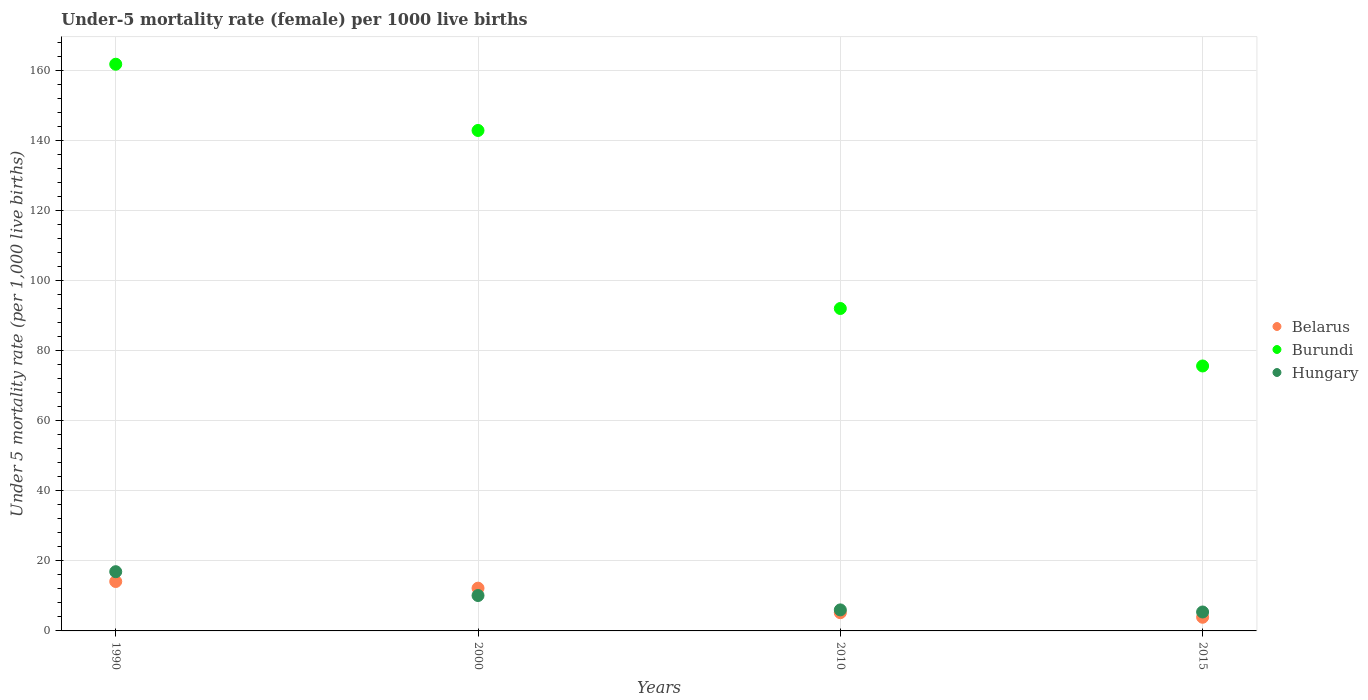What is the under-five mortality rate in Burundi in 2015?
Offer a terse response. 75.6. Across all years, what is the minimum under-five mortality rate in Hungary?
Offer a very short reply. 5.4. In which year was the under-five mortality rate in Hungary minimum?
Provide a short and direct response. 2015. What is the total under-five mortality rate in Hungary in the graph?
Your answer should be compact. 38.4. What is the difference between the under-five mortality rate in Belarus in 1990 and that in 2010?
Your answer should be very brief. 8.9. What is the difference between the under-five mortality rate in Hungary in 2015 and the under-five mortality rate in Burundi in 1990?
Your answer should be compact. -156.3. What is the average under-five mortality rate in Belarus per year?
Make the answer very short. 8.85. In the year 2010, what is the difference between the under-five mortality rate in Hungary and under-five mortality rate in Burundi?
Provide a succinct answer. -86. What is the ratio of the under-five mortality rate in Burundi in 1990 to that in 2015?
Ensure brevity in your answer.  2.14. Is the under-five mortality rate in Belarus in 1990 less than that in 2010?
Give a very brief answer. No. What is the difference between the highest and the second highest under-five mortality rate in Burundi?
Your response must be concise. 18.9. What is the difference between the highest and the lowest under-five mortality rate in Hungary?
Offer a terse response. 11.5. Is the sum of the under-five mortality rate in Hungary in 1990 and 2015 greater than the maximum under-five mortality rate in Belarus across all years?
Your answer should be very brief. Yes. Is the under-five mortality rate in Hungary strictly less than the under-five mortality rate in Belarus over the years?
Ensure brevity in your answer.  No. How many dotlines are there?
Give a very brief answer. 3. How many legend labels are there?
Your answer should be compact. 3. How are the legend labels stacked?
Your answer should be very brief. Vertical. What is the title of the graph?
Ensure brevity in your answer.  Under-5 mortality rate (female) per 1000 live births. What is the label or title of the X-axis?
Provide a succinct answer. Years. What is the label or title of the Y-axis?
Provide a succinct answer. Under 5 mortality rate (per 1,0 live births). What is the Under 5 mortality rate (per 1,000 live births) in Belarus in 1990?
Make the answer very short. 14.1. What is the Under 5 mortality rate (per 1,000 live births) of Burundi in 1990?
Your answer should be very brief. 161.7. What is the Under 5 mortality rate (per 1,000 live births) of Hungary in 1990?
Offer a terse response. 16.9. What is the Under 5 mortality rate (per 1,000 live births) in Burundi in 2000?
Provide a short and direct response. 142.8. What is the Under 5 mortality rate (per 1,000 live births) of Hungary in 2000?
Provide a short and direct response. 10.1. What is the Under 5 mortality rate (per 1,000 live births) in Burundi in 2010?
Your response must be concise. 92. What is the Under 5 mortality rate (per 1,000 live births) of Burundi in 2015?
Offer a terse response. 75.6. Across all years, what is the maximum Under 5 mortality rate (per 1,000 live births) of Belarus?
Offer a very short reply. 14.1. Across all years, what is the maximum Under 5 mortality rate (per 1,000 live births) of Burundi?
Give a very brief answer. 161.7. Across all years, what is the maximum Under 5 mortality rate (per 1,000 live births) in Hungary?
Keep it short and to the point. 16.9. Across all years, what is the minimum Under 5 mortality rate (per 1,000 live births) of Belarus?
Your response must be concise. 3.9. Across all years, what is the minimum Under 5 mortality rate (per 1,000 live births) of Burundi?
Your answer should be compact. 75.6. Across all years, what is the minimum Under 5 mortality rate (per 1,000 live births) of Hungary?
Provide a short and direct response. 5.4. What is the total Under 5 mortality rate (per 1,000 live births) of Belarus in the graph?
Offer a terse response. 35.4. What is the total Under 5 mortality rate (per 1,000 live births) of Burundi in the graph?
Provide a succinct answer. 472.1. What is the total Under 5 mortality rate (per 1,000 live births) in Hungary in the graph?
Ensure brevity in your answer.  38.4. What is the difference between the Under 5 mortality rate (per 1,000 live births) of Belarus in 1990 and that in 2000?
Provide a short and direct response. 1.9. What is the difference between the Under 5 mortality rate (per 1,000 live births) in Burundi in 1990 and that in 2010?
Ensure brevity in your answer.  69.7. What is the difference between the Under 5 mortality rate (per 1,000 live births) in Burundi in 1990 and that in 2015?
Make the answer very short. 86.1. What is the difference between the Under 5 mortality rate (per 1,000 live births) in Belarus in 2000 and that in 2010?
Provide a succinct answer. 7. What is the difference between the Under 5 mortality rate (per 1,000 live births) of Burundi in 2000 and that in 2010?
Give a very brief answer. 50.8. What is the difference between the Under 5 mortality rate (per 1,000 live births) of Belarus in 2000 and that in 2015?
Give a very brief answer. 8.3. What is the difference between the Under 5 mortality rate (per 1,000 live births) in Burundi in 2000 and that in 2015?
Provide a succinct answer. 67.2. What is the difference between the Under 5 mortality rate (per 1,000 live births) in Hungary in 2000 and that in 2015?
Make the answer very short. 4.7. What is the difference between the Under 5 mortality rate (per 1,000 live births) of Burundi in 2010 and that in 2015?
Keep it short and to the point. 16.4. What is the difference between the Under 5 mortality rate (per 1,000 live births) of Hungary in 2010 and that in 2015?
Give a very brief answer. 0.6. What is the difference between the Under 5 mortality rate (per 1,000 live births) in Belarus in 1990 and the Under 5 mortality rate (per 1,000 live births) in Burundi in 2000?
Your answer should be compact. -128.7. What is the difference between the Under 5 mortality rate (per 1,000 live births) of Burundi in 1990 and the Under 5 mortality rate (per 1,000 live births) of Hungary in 2000?
Make the answer very short. 151.6. What is the difference between the Under 5 mortality rate (per 1,000 live births) of Belarus in 1990 and the Under 5 mortality rate (per 1,000 live births) of Burundi in 2010?
Your answer should be very brief. -77.9. What is the difference between the Under 5 mortality rate (per 1,000 live births) in Burundi in 1990 and the Under 5 mortality rate (per 1,000 live births) in Hungary in 2010?
Offer a very short reply. 155.7. What is the difference between the Under 5 mortality rate (per 1,000 live births) in Belarus in 1990 and the Under 5 mortality rate (per 1,000 live births) in Burundi in 2015?
Your answer should be compact. -61.5. What is the difference between the Under 5 mortality rate (per 1,000 live births) in Belarus in 1990 and the Under 5 mortality rate (per 1,000 live births) in Hungary in 2015?
Offer a terse response. 8.7. What is the difference between the Under 5 mortality rate (per 1,000 live births) in Burundi in 1990 and the Under 5 mortality rate (per 1,000 live births) in Hungary in 2015?
Provide a short and direct response. 156.3. What is the difference between the Under 5 mortality rate (per 1,000 live births) of Belarus in 2000 and the Under 5 mortality rate (per 1,000 live births) of Burundi in 2010?
Give a very brief answer. -79.8. What is the difference between the Under 5 mortality rate (per 1,000 live births) of Belarus in 2000 and the Under 5 mortality rate (per 1,000 live births) of Hungary in 2010?
Provide a succinct answer. 6.2. What is the difference between the Under 5 mortality rate (per 1,000 live births) of Burundi in 2000 and the Under 5 mortality rate (per 1,000 live births) of Hungary in 2010?
Give a very brief answer. 136.8. What is the difference between the Under 5 mortality rate (per 1,000 live births) of Belarus in 2000 and the Under 5 mortality rate (per 1,000 live births) of Burundi in 2015?
Provide a succinct answer. -63.4. What is the difference between the Under 5 mortality rate (per 1,000 live births) of Belarus in 2000 and the Under 5 mortality rate (per 1,000 live births) of Hungary in 2015?
Make the answer very short. 6.8. What is the difference between the Under 5 mortality rate (per 1,000 live births) in Burundi in 2000 and the Under 5 mortality rate (per 1,000 live births) in Hungary in 2015?
Offer a very short reply. 137.4. What is the difference between the Under 5 mortality rate (per 1,000 live births) in Belarus in 2010 and the Under 5 mortality rate (per 1,000 live births) in Burundi in 2015?
Your response must be concise. -70.4. What is the difference between the Under 5 mortality rate (per 1,000 live births) of Burundi in 2010 and the Under 5 mortality rate (per 1,000 live births) of Hungary in 2015?
Your response must be concise. 86.6. What is the average Under 5 mortality rate (per 1,000 live births) in Belarus per year?
Offer a terse response. 8.85. What is the average Under 5 mortality rate (per 1,000 live births) in Burundi per year?
Offer a very short reply. 118.03. What is the average Under 5 mortality rate (per 1,000 live births) in Hungary per year?
Your answer should be compact. 9.6. In the year 1990, what is the difference between the Under 5 mortality rate (per 1,000 live births) of Belarus and Under 5 mortality rate (per 1,000 live births) of Burundi?
Make the answer very short. -147.6. In the year 1990, what is the difference between the Under 5 mortality rate (per 1,000 live births) in Burundi and Under 5 mortality rate (per 1,000 live births) in Hungary?
Your answer should be compact. 144.8. In the year 2000, what is the difference between the Under 5 mortality rate (per 1,000 live births) of Belarus and Under 5 mortality rate (per 1,000 live births) of Burundi?
Your answer should be very brief. -130.6. In the year 2000, what is the difference between the Under 5 mortality rate (per 1,000 live births) of Burundi and Under 5 mortality rate (per 1,000 live births) of Hungary?
Keep it short and to the point. 132.7. In the year 2010, what is the difference between the Under 5 mortality rate (per 1,000 live births) of Belarus and Under 5 mortality rate (per 1,000 live births) of Burundi?
Offer a very short reply. -86.8. In the year 2010, what is the difference between the Under 5 mortality rate (per 1,000 live births) in Belarus and Under 5 mortality rate (per 1,000 live births) in Hungary?
Make the answer very short. -0.8. In the year 2010, what is the difference between the Under 5 mortality rate (per 1,000 live births) in Burundi and Under 5 mortality rate (per 1,000 live births) in Hungary?
Offer a very short reply. 86. In the year 2015, what is the difference between the Under 5 mortality rate (per 1,000 live births) in Belarus and Under 5 mortality rate (per 1,000 live births) in Burundi?
Your response must be concise. -71.7. In the year 2015, what is the difference between the Under 5 mortality rate (per 1,000 live births) of Burundi and Under 5 mortality rate (per 1,000 live births) of Hungary?
Your answer should be very brief. 70.2. What is the ratio of the Under 5 mortality rate (per 1,000 live births) in Belarus in 1990 to that in 2000?
Offer a terse response. 1.16. What is the ratio of the Under 5 mortality rate (per 1,000 live births) of Burundi in 1990 to that in 2000?
Offer a terse response. 1.13. What is the ratio of the Under 5 mortality rate (per 1,000 live births) of Hungary in 1990 to that in 2000?
Your answer should be compact. 1.67. What is the ratio of the Under 5 mortality rate (per 1,000 live births) in Belarus in 1990 to that in 2010?
Your answer should be very brief. 2.71. What is the ratio of the Under 5 mortality rate (per 1,000 live births) of Burundi in 1990 to that in 2010?
Ensure brevity in your answer.  1.76. What is the ratio of the Under 5 mortality rate (per 1,000 live births) of Hungary in 1990 to that in 2010?
Make the answer very short. 2.82. What is the ratio of the Under 5 mortality rate (per 1,000 live births) of Belarus in 1990 to that in 2015?
Your response must be concise. 3.62. What is the ratio of the Under 5 mortality rate (per 1,000 live births) in Burundi in 1990 to that in 2015?
Your response must be concise. 2.14. What is the ratio of the Under 5 mortality rate (per 1,000 live births) in Hungary in 1990 to that in 2015?
Offer a very short reply. 3.13. What is the ratio of the Under 5 mortality rate (per 1,000 live births) in Belarus in 2000 to that in 2010?
Provide a succinct answer. 2.35. What is the ratio of the Under 5 mortality rate (per 1,000 live births) in Burundi in 2000 to that in 2010?
Your answer should be compact. 1.55. What is the ratio of the Under 5 mortality rate (per 1,000 live births) of Hungary in 2000 to that in 2010?
Offer a very short reply. 1.68. What is the ratio of the Under 5 mortality rate (per 1,000 live births) of Belarus in 2000 to that in 2015?
Provide a short and direct response. 3.13. What is the ratio of the Under 5 mortality rate (per 1,000 live births) in Burundi in 2000 to that in 2015?
Your answer should be compact. 1.89. What is the ratio of the Under 5 mortality rate (per 1,000 live births) of Hungary in 2000 to that in 2015?
Your response must be concise. 1.87. What is the ratio of the Under 5 mortality rate (per 1,000 live births) in Belarus in 2010 to that in 2015?
Provide a succinct answer. 1.33. What is the ratio of the Under 5 mortality rate (per 1,000 live births) in Burundi in 2010 to that in 2015?
Provide a short and direct response. 1.22. What is the difference between the highest and the second highest Under 5 mortality rate (per 1,000 live births) of Belarus?
Offer a very short reply. 1.9. What is the difference between the highest and the second highest Under 5 mortality rate (per 1,000 live births) of Burundi?
Ensure brevity in your answer.  18.9. What is the difference between the highest and the second highest Under 5 mortality rate (per 1,000 live births) in Hungary?
Your answer should be very brief. 6.8. What is the difference between the highest and the lowest Under 5 mortality rate (per 1,000 live births) in Belarus?
Keep it short and to the point. 10.2. What is the difference between the highest and the lowest Under 5 mortality rate (per 1,000 live births) of Burundi?
Give a very brief answer. 86.1. What is the difference between the highest and the lowest Under 5 mortality rate (per 1,000 live births) in Hungary?
Offer a very short reply. 11.5. 